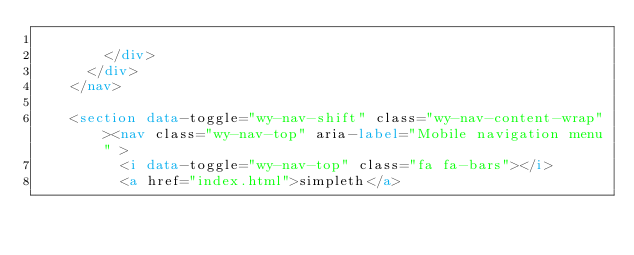<code> <loc_0><loc_0><loc_500><loc_500><_HTML_>
        </div>
      </div>
    </nav>

    <section data-toggle="wy-nav-shift" class="wy-nav-content-wrap"><nav class="wy-nav-top" aria-label="Mobile navigation menu" >
          <i data-toggle="wy-nav-top" class="fa fa-bars"></i>
          <a href="index.html">simpleth</a></code> 